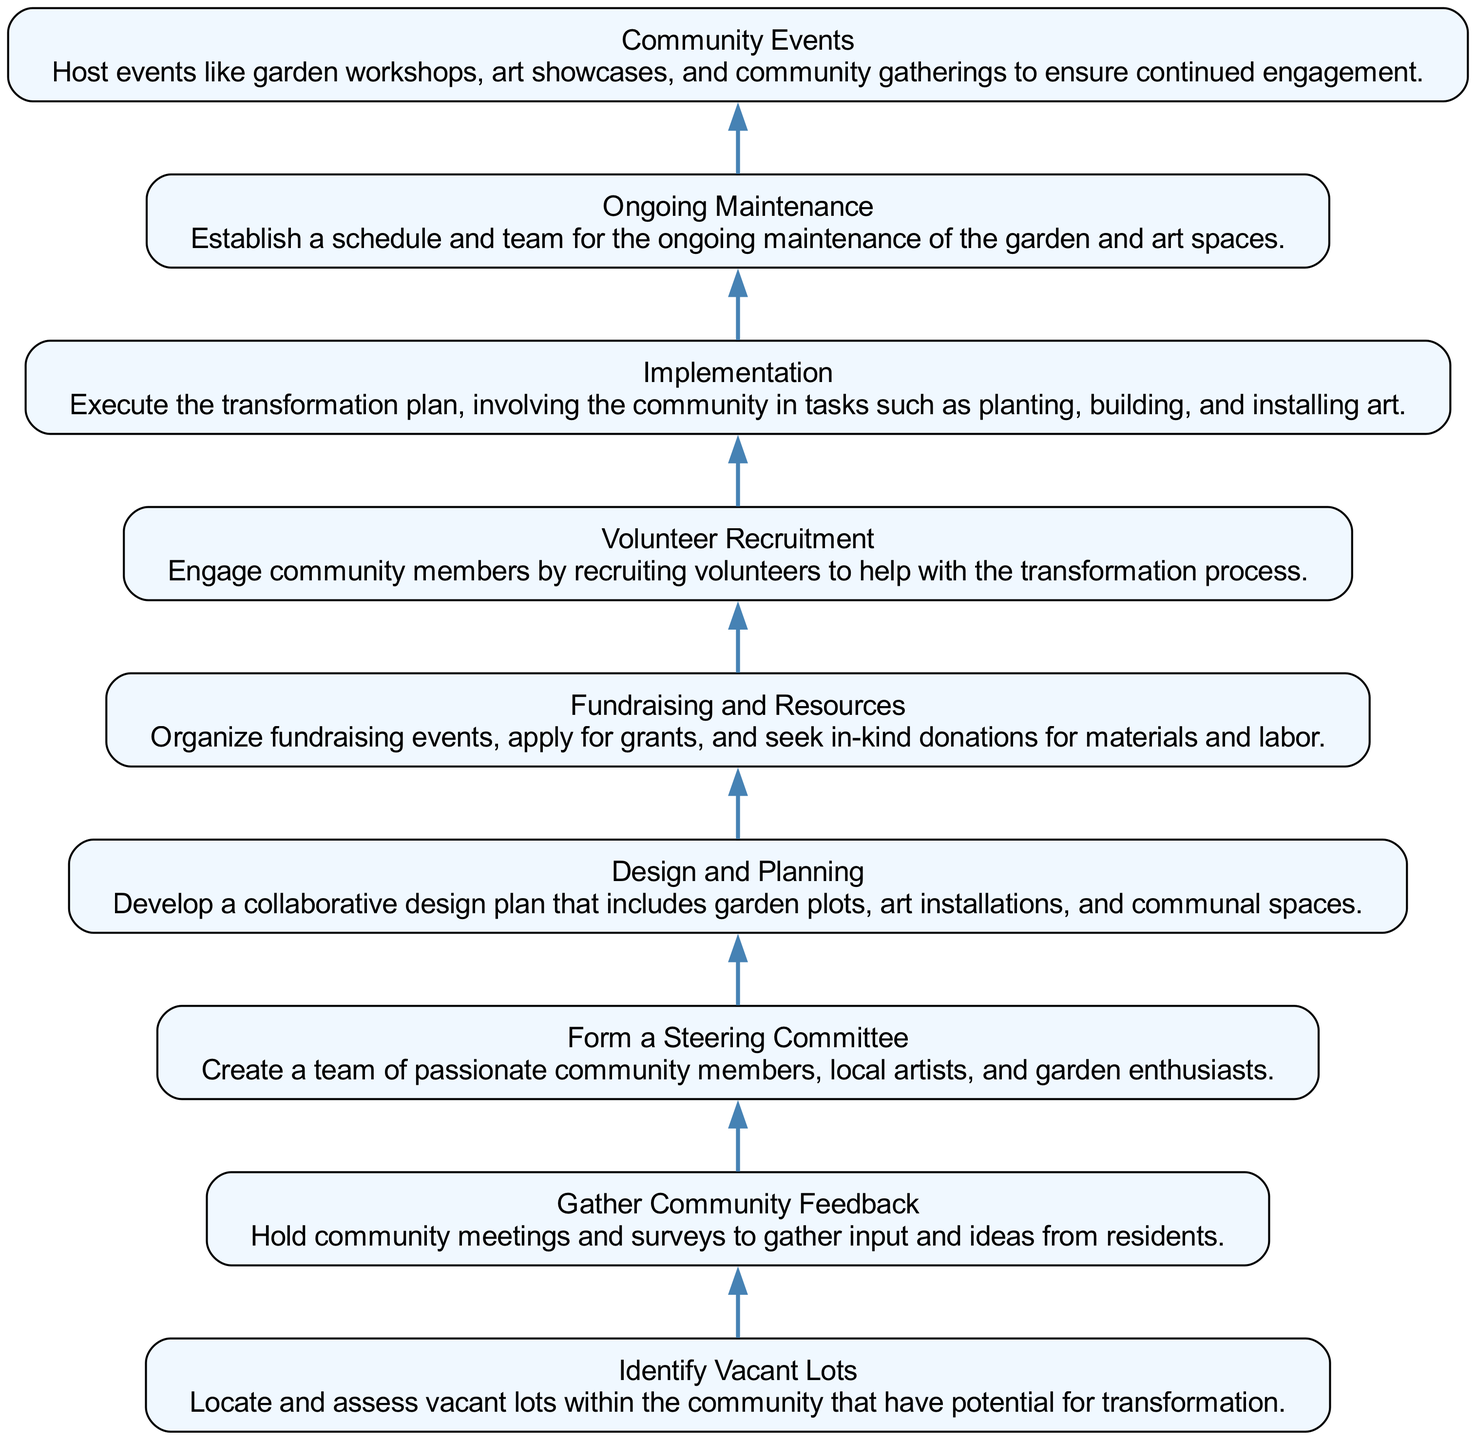What is the first node in the diagram? The first node at the bottom of the flow chart is labeled "Identify Vacant Lots." This is determined by looking at the starting point of the flow in the bottom-to-up structure.
Answer: Identify Vacant Lots How many total nodes are in the diagram? There are a total of nine nodes in the flow chart. This can be confirmed by counting each of the distinct steps listed in the flow from bottom to up.
Answer: Nine What connects "Form a Steering Committee" to the next step? The edge connects "Form a Steering Committee" to the following node "Design and Planning." This connection is shown by a directed edge that leads from the name of one node to the name of the next, indicating the flow of the process.
Answer: Design and Planning What is the last step in the transformation process? The last step seen at the top of the flow chart is "Community Events." This is determined by identifying the endpoint of the flow, which is the topmost node.
Answer: Community Events Which step directly follows "Gather Community Feedback"? The step that follows "Gather Community Feedback" is "Form a Steering Committee." This is derived from tracing the flow upwards from the node in question to identify what comes next in the sequence.
Answer: Form a Steering Committee How many steps are between "Implementation" and "Ongoing Maintenance"? There is one step between "Implementation" and "Ongoing Maintenance," which is the "Ongoing Maintenance" node itself. By counting the nodes between these two, we see that "Ongoing Maintenance" directly follows "Implementation."
Answer: One What is the main activity described in "Design and Planning"? The main activity in "Design and Planning" is to "Develop a collaborative design plan that includes garden plots, art installations, and communal spaces." This can be seen as a direct description placed in the node itself.
Answer: Develop a collaborative design plan What is necessary to support "Fundraising and Resources"? Fundraising events, applying for grants, and seeking in-kind donations are necessary to support "Fundraising and Resources." This is a summarization based on the description provided within the node in the diagram.
Answer: Fundraising events, grants, donations What is the role of volunteers in the transformation process? Volunteers are engaged to help with the transformation process as indicated in the "Volunteer Recruitment" node. The description states that engaging community members includes recruiting volunteers for various tasks in the transition.
Answer: Help with the transformation process 